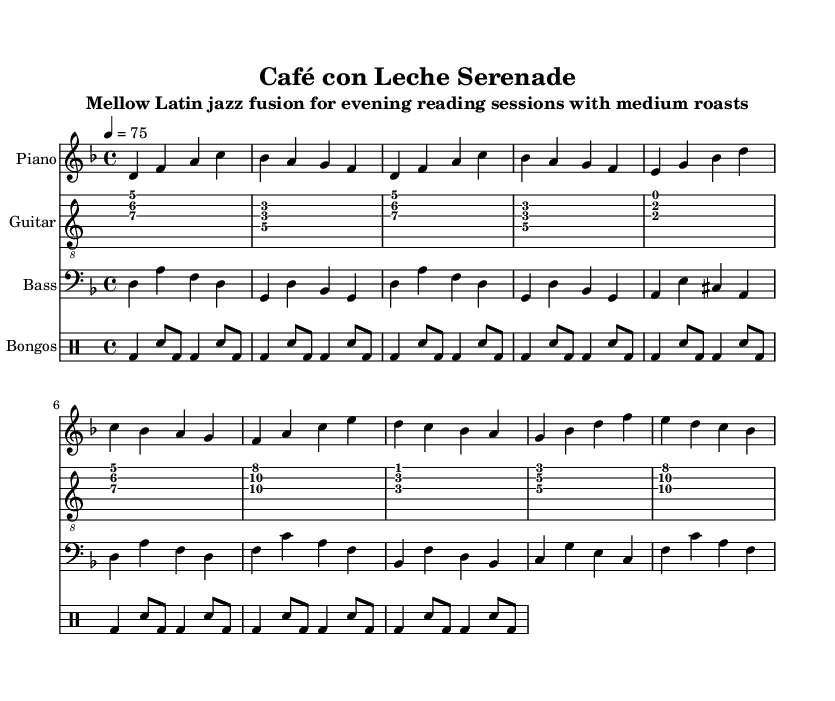What is the key signature of this music? The key signature shown in the staff indicates D minor, which has one flat (B flat). This can be verified by looking at the notes presented in the music, where B flat appears frequently, indicating the use of the D minor key signature.
Answer: D minor What is the time signature of this music? The time signature is indicated at the beginning of the score as 4/4. This means there are four beats per measure and the quarter note gets one beat. This can be confirmed by counting the beats in the measures drawn in the sheet music.
Answer: 4/4 What is the tempo marking of this music? The tempo marking indicated is 4 = 75, meaning there are 75 beats per minute. Tempo markings are generally given above the music staff and can be identified directly in the sheet music.
Answer: 75 How many instruments are included in this score? There are four instruments indicated in the score: piano, guitar, bass, and bongos. This can be counted by looking at the different staves present at the beginning of the score, where each instrument is listed.
Answer: Four Which style of music does this composition represent? The subtitle of the composition indicates that it represents Mellow Latin jazz fusion, which is a blend of jazz, Latin rhythms, and mellow sounds suitable for an evening reading session. This can be inferred directly from the title and subtitle within the score.
Answer: Mellow Latin jazz fusion What are the rhythmic elements used in the bongos section? The rhythmic elements in the bongos section are based on a combination of bass drum (bd) and snare drum (sn) patterns. The structure shows alternating beats that provide a foundational rhythm common in Latin music styles. This can be understood by examining the drum notation in the music sheet.
Answer: Bass and snare patterns 